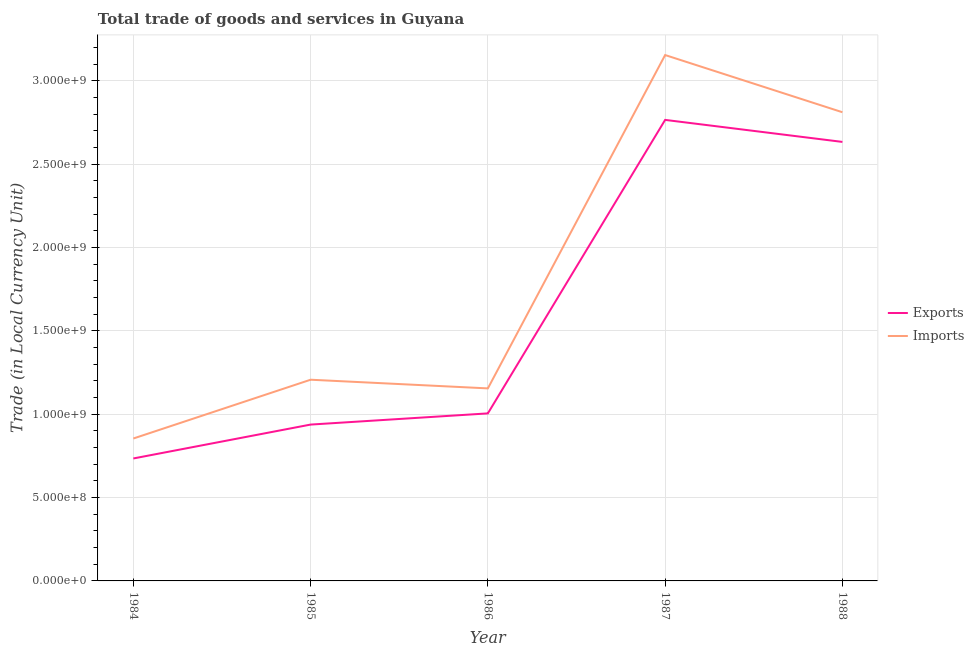How many different coloured lines are there?
Make the answer very short. 2. Does the line corresponding to export of goods and services intersect with the line corresponding to imports of goods and services?
Your answer should be compact. No. What is the export of goods and services in 1986?
Your answer should be compact. 1.00e+09. Across all years, what is the maximum imports of goods and services?
Offer a terse response. 3.15e+09. Across all years, what is the minimum export of goods and services?
Your answer should be very brief. 7.34e+08. In which year was the imports of goods and services maximum?
Keep it short and to the point. 1987. What is the total export of goods and services in the graph?
Ensure brevity in your answer.  8.07e+09. What is the difference between the imports of goods and services in 1985 and that in 1986?
Make the answer very short. 5.20e+07. What is the difference between the imports of goods and services in 1986 and the export of goods and services in 1985?
Offer a terse response. 2.17e+08. What is the average export of goods and services per year?
Make the answer very short. 1.61e+09. In the year 1984, what is the difference between the imports of goods and services and export of goods and services?
Offer a very short reply. 1.20e+08. In how many years, is the imports of goods and services greater than 1200000000 LCU?
Offer a very short reply. 3. What is the ratio of the imports of goods and services in 1986 to that in 1988?
Give a very brief answer. 0.41. Is the export of goods and services in 1984 less than that in 1985?
Give a very brief answer. Yes. Is the difference between the export of goods and services in 1985 and 1988 greater than the difference between the imports of goods and services in 1985 and 1988?
Your response must be concise. No. What is the difference between the highest and the second highest export of goods and services?
Keep it short and to the point. 1.32e+08. What is the difference between the highest and the lowest export of goods and services?
Offer a terse response. 2.03e+09. In how many years, is the imports of goods and services greater than the average imports of goods and services taken over all years?
Your response must be concise. 2. Is the sum of the export of goods and services in 1985 and 1988 greater than the maximum imports of goods and services across all years?
Provide a succinct answer. Yes. How many years are there in the graph?
Ensure brevity in your answer.  5. What is the difference between two consecutive major ticks on the Y-axis?
Your response must be concise. 5.00e+08. Does the graph contain grids?
Offer a very short reply. Yes. Where does the legend appear in the graph?
Provide a succinct answer. Center right. What is the title of the graph?
Give a very brief answer. Total trade of goods and services in Guyana. Does "Formally registered" appear as one of the legend labels in the graph?
Offer a very short reply. No. What is the label or title of the Y-axis?
Your answer should be very brief. Trade (in Local Currency Unit). What is the Trade (in Local Currency Unit) in Exports in 1984?
Offer a very short reply. 7.34e+08. What is the Trade (in Local Currency Unit) in Imports in 1984?
Offer a very short reply. 8.54e+08. What is the Trade (in Local Currency Unit) in Exports in 1985?
Provide a succinct answer. 9.38e+08. What is the Trade (in Local Currency Unit) in Imports in 1985?
Your response must be concise. 1.21e+09. What is the Trade (in Local Currency Unit) in Exports in 1986?
Give a very brief answer. 1.00e+09. What is the Trade (in Local Currency Unit) of Imports in 1986?
Ensure brevity in your answer.  1.15e+09. What is the Trade (in Local Currency Unit) of Exports in 1987?
Make the answer very short. 2.76e+09. What is the Trade (in Local Currency Unit) in Imports in 1987?
Offer a very short reply. 3.15e+09. What is the Trade (in Local Currency Unit) of Exports in 1988?
Your answer should be compact. 2.63e+09. What is the Trade (in Local Currency Unit) in Imports in 1988?
Offer a terse response. 2.81e+09. Across all years, what is the maximum Trade (in Local Currency Unit) of Exports?
Give a very brief answer. 2.76e+09. Across all years, what is the maximum Trade (in Local Currency Unit) of Imports?
Your answer should be compact. 3.15e+09. Across all years, what is the minimum Trade (in Local Currency Unit) in Exports?
Your answer should be very brief. 7.34e+08. Across all years, what is the minimum Trade (in Local Currency Unit) of Imports?
Keep it short and to the point. 8.54e+08. What is the total Trade (in Local Currency Unit) in Exports in the graph?
Offer a terse response. 8.07e+09. What is the total Trade (in Local Currency Unit) of Imports in the graph?
Provide a succinct answer. 9.18e+09. What is the difference between the Trade (in Local Currency Unit) of Exports in 1984 and that in 1985?
Give a very brief answer. -2.03e+08. What is the difference between the Trade (in Local Currency Unit) of Imports in 1984 and that in 1985?
Keep it short and to the point. -3.53e+08. What is the difference between the Trade (in Local Currency Unit) in Exports in 1984 and that in 1986?
Make the answer very short. -2.70e+08. What is the difference between the Trade (in Local Currency Unit) of Imports in 1984 and that in 1986?
Keep it short and to the point. -3.01e+08. What is the difference between the Trade (in Local Currency Unit) of Exports in 1984 and that in 1987?
Give a very brief answer. -2.03e+09. What is the difference between the Trade (in Local Currency Unit) in Imports in 1984 and that in 1987?
Offer a very short reply. -2.30e+09. What is the difference between the Trade (in Local Currency Unit) in Exports in 1984 and that in 1988?
Offer a very short reply. -1.90e+09. What is the difference between the Trade (in Local Currency Unit) in Imports in 1984 and that in 1988?
Provide a short and direct response. -1.96e+09. What is the difference between the Trade (in Local Currency Unit) of Exports in 1985 and that in 1986?
Make the answer very short. -6.71e+07. What is the difference between the Trade (in Local Currency Unit) of Imports in 1985 and that in 1986?
Provide a short and direct response. 5.20e+07. What is the difference between the Trade (in Local Currency Unit) in Exports in 1985 and that in 1987?
Offer a very short reply. -1.83e+09. What is the difference between the Trade (in Local Currency Unit) of Imports in 1985 and that in 1987?
Make the answer very short. -1.95e+09. What is the difference between the Trade (in Local Currency Unit) of Exports in 1985 and that in 1988?
Your response must be concise. -1.70e+09. What is the difference between the Trade (in Local Currency Unit) of Imports in 1985 and that in 1988?
Ensure brevity in your answer.  -1.60e+09. What is the difference between the Trade (in Local Currency Unit) in Exports in 1986 and that in 1987?
Make the answer very short. -1.76e+09. What is the difference between the Trade (in Local Currency Unit) in Imports in 1986 and that in 1987?
Your answer should be compact. -2.00e+09. What is the difference between the Trade (in Local Currency Unit) in Exports in 1986 and that in 1988?
Offer a terse response. -1.63e+09. What is the difference between the Trade (in Local Currency Unit) of Imports in 1986 and that in 1988?
Give a very brief answer. -1.66e+09. What is the difference between the Trade (in Local Currency Unit) of Exports in 1987 and that in 1988?
Your response must be concise. 1.32e+08. What is the difference between the Trade (in Local Currency Unit) of Imports in 1987 and that in 1988?
Keep it short and to the point. 3.43e+08. What is the difference between the Trade (in Local Currency Unit) in Exports in 1984 and the Trade (in Local Currency Unit) in Imports in 1985?
Your answer should be compact. -4.72e+08. What is the difference between the Trade (in Local Currency Unit) in Exports in 1984 and the Trade (in Local Currency Unit) in Imports in 1986?
Your answer should be compact. -4.20e+08. What is the difference between the Trade (in Local Currency Unit) of Exports in 1984 and the Trade (in Local Currency Unit) of Imports in 1987?
Ensure brevity in your answer.  -2.42e+09. What is the difference between the Trade (in Local Currency Unit) of Exports in 1984 and the Trade (in Local Currency Unit) of Imports in 1988?
Your answer should be compact. -2.08e+09. What is the difference between the Trade (in Local Currency Unit) of Exports in 1985 and the Trade (in Local Currency Unit) of Imports in 1986?
Provide a short and direct response. -2.17e+08. What is the difference between the Trade (in Local Currency Unit) of Exports in 1985 and the Trade (in Local Currency Unit) of Imports in 1987?
Give a very brief answer. -2.22e+09. What is the difference between the Trade (in Local Currency Unit) in Exports in 1985 and the Trade (in Local Currency Unit) in Imports in 1988?
Provide a succinct answer. -1.87e+09. What is the difference between the Trade (in Local Currency Unit) in Exports in 1986 and the Trade (in Local Currency Unit) in Imports in 1987?
Offer a terse response. -2.15e+09. What is the difference between the Trade (in Local Currency Unit) of Exports in 1986 and the Trade (in Local Currency Unit) of Imports in 1988?
Make the answer very short. -1.81e+09. What is the difference between the Trade (in Local Currency Unit) in Exports in 1987 and the Trade (in Local Currency Unit) in Imports in 1988?
Provide a succinct answer. -4.60e+07. What is the average Trade (in Local Currency Unit) in Exports per year?
Offer a terse response. 1.61e+09. What is the average Trade (in Local Currency Unit) of Imports per year?
Keep it short and to the point. 1.84e+09. In the year 1984, what is the difference between the Trade (in Local Currency Unit) of Exports and Trade (in Local Currency Unit) of Imports?
Your response must be concise. -1.20e+08. In the year 1985, what is the difference between the Trade (in Local Currency Unit) of Exports and Trade (in Local Currency Unit) of Imports?
Offer a very short reply. -2.69e+08. In the year 1986, what is the difference between the Trade (in Local Currency Unit) in Exports and Trade (in Local Currency Unit) in Imports?
Provide a short and direct response. -1.50e+08. In the year 1987, what is the difference between the Trade (in Local Currency Unit) in Exports and Trade (in Local Currency Unit) in Imports?
Keep it short and to the point. -3.89e+08. In the year 1988, what is the difference between the Trade (in Local Currency Unit) of Exports and Trade (in Local Currency Unit) of Imports?
Your answer should be very brief. -1.78e+08. What is the ratio of the Trade (in Local Currency Unit) in Exports in 1984 to that in 1985?
Provide a short and direct response. 0.78. What is the ratio of the Trade (in Local Currency Unit) in Imports in 1984 to that in 1985?
Keep it short and to the point. 0.71. What is the ratio of the Trade (in Local Currency Unit) of Exports in 1984 to that in 1986?
Provide a short and direct response. 0.73. What is the ratio of the Trade (in Local Currency Unit) of Imports in 1984 to that in 1986?
Offer a terse response. 0.74. What is the ratio of the Trade (in Local Currency Unit) in Exports in 1984 to that in 1987?
Ensure brevity in your answer.  0.27. What is the ratio of the Trade (in Local Currency Unit) in Imports in 1984 to that in 1987?
Give a very brief answer. 0.27. What is the ratio of the Trade (in Local Currency Unit) of Exports in 1984 to that in 1988?
Your response must be concise. 0.28. What is the ratio of the Trade (in Local Currency Unit) of Imports in 1984 to that in 1988?
Your answer should be very brief. 0.3. What is the ratio of the Trade (in Local Currency Unit) in Exports in 1985 to that in 1986?
Provide a succinct answer. 0.93. What is the ratio of the Trade (in Local Currency Unit) of Imports in 1985 to that in 1986?
Provide a succinct answer. 1.04. What is the ratio of the Trade (in Local Currency Unit) of Exports in 1985 to that in 1987?
Ensure brevity in your answer.  0.34. What is the ratio of the Trade (in Local Currency Unit) in Imports in 1985 to that in 1987?
Offer a terse response. 0.38. What is the ratio of the Trade (in Local Currency Unit) in Exports in 1985 to that in 1988?
Offer a very short reply. 0.36. What is the ratio of the Trade (in Local Currency Unit) in Imports in 1985 to that in 1988?
Your response must be concise. 0.43. What is the ratio of the Trade (in Local Currency Unit) in Exports in 1986 to that in 1987?
Provide a succinct answer. 0.36. What is the ratio of the Trade (in Local Currency Unit) in Imports in 1986 to that in 1987?
Your response must be concise. 0.37. What is the ratio of the Trade (in Local Currency Unit) in Exports in 1986 to that in 1988?
Your answer should be very brief. 0.38. What is the ratio of the Trade (in Local Currency Unit) in Imports in 1986 to that in 1988?
Make the answer very short. 0.41. What is the ratio of the Trade (in Local Currency Unit) in Exports in 1987 to that in 1988?
Offer a terse response. 1.05. What is the ratio of the Trade (in Local Currency Unit) of Imports in 1987 to that in 1988?
Your answer should be very brief. 1.12. What is the difference between the highest and the second highest Trade (in Local Currency Unit) of Exports?
Your answer should be compact. 1.32e+08. What is the difference between the highest and the second highest Trade (in Local Currency Unit) in Imports?
Offer a terse response. 3.43e+08. What is the difference between the highest and the lowest Trade (in Local Currency Unit) in Exports?
Offer a terse response. 2.03e+09. What is the difference between the highest and the lowest Trade (in Local Currency Unit) in Imports?
Your response must be concise. 2.30e+09. 